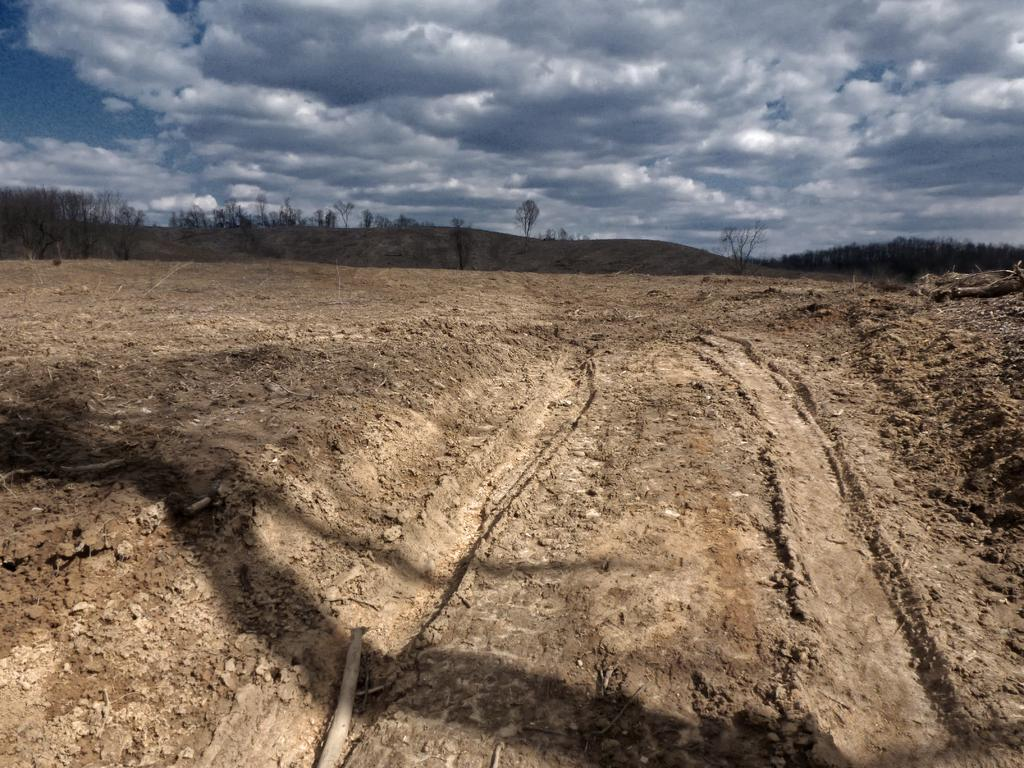What is the primary surface visible in the image? There is a ground in the image. Where are the trees located in the image? The trees are on the left side of the image. What can be seen in the sky in the image? There are clouds in the sky. What type of wire can be seen hanging from the edge of the image? There is no wire present in the image. 